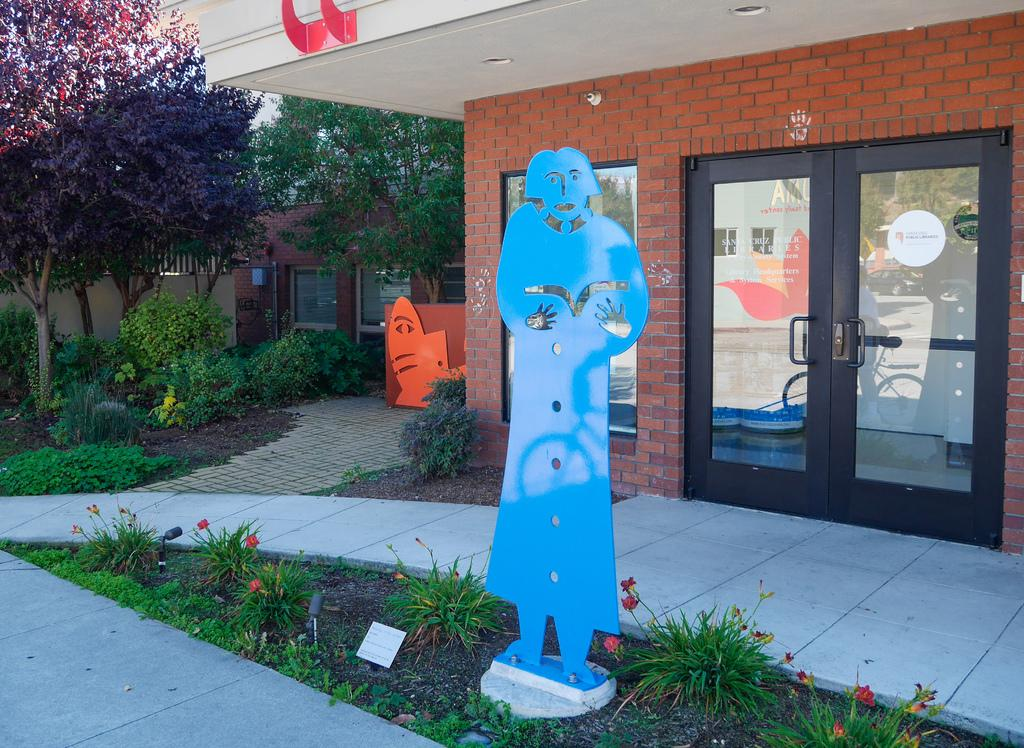What type of structures can be seen in the image? There are houses in the image. What type of door is visible in the image? There is a glass door in the image. What other objects can be seen in the image besides houses and the glass door? There are various objects, plants, a board, and flowers in the image. What type of vegetation is present in the image? There are plants, flowers, and trees in the image. What type of bean is growing on the houses in the image? There are no beans growing on the houses in the image; it features houses, a glass door, various objects, plants, a board, and flowers. 